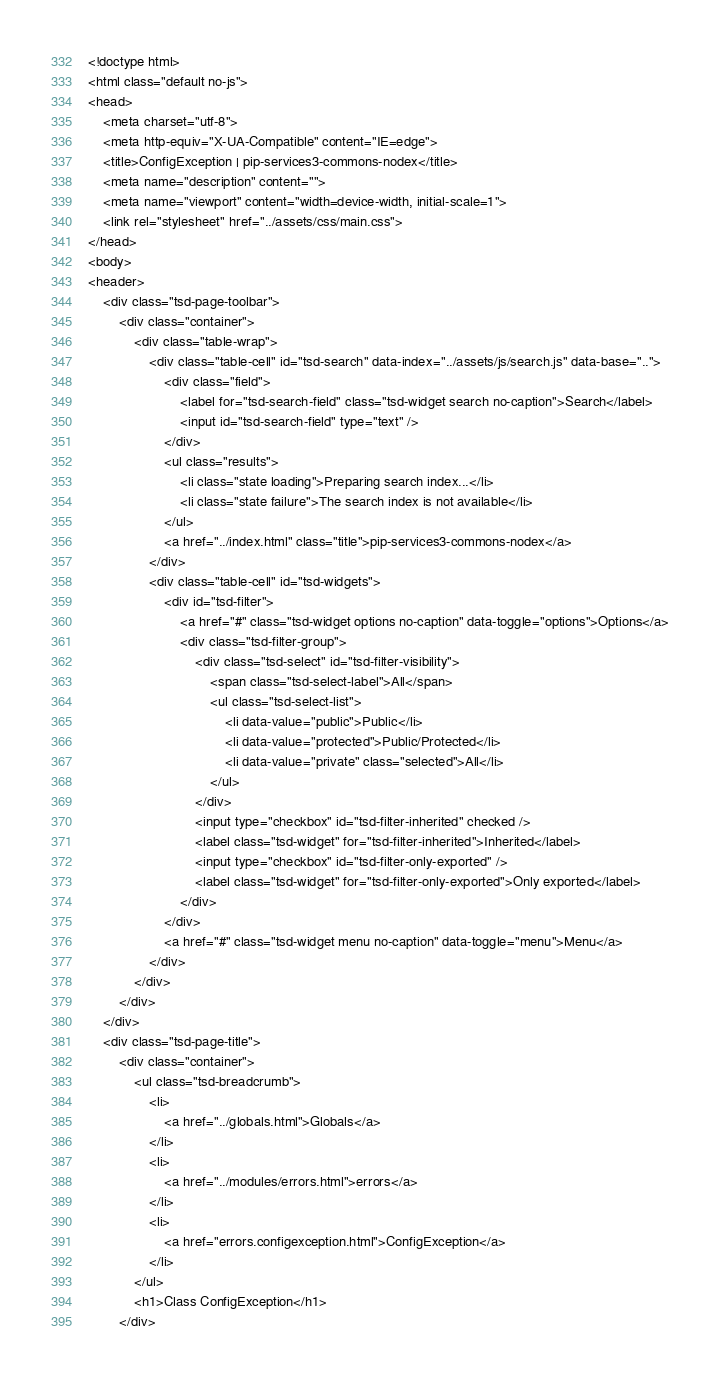<code> <loc_0><loc_0><loc_500><loc_500><_HTML_><!doctype html>
<html class="default no-js">
<head>
	<meta charset="utf-8">
	<meta http-equiv="X-UA-Compatible" content="IE=edge">
	<title>ConfigException | pip-services3-commons-nodex</title>
	<meta name="description" content="">
	<meta name="viewport" content="width=device-width, initial-scale=1">
	<link rel="stylesheet" href="../assets/css/main.css">
</head>
<body>
<header>
	<div class="tsd-page-toolbar">
		<div class="container">
			<div class="table-wrap">
				<div class="table-cell" id="tsd-search" data-index="../assets/js/search.js" data-base="..">
					<div class="field">
						<label for="tsd-search-field" class="tsd-widget search no-caption">Search</label>
						<input id="tsd-search-field" type="text" />
					</div>
					<ul class="results">
						<li class="state loading">Preparing search index...</li>
						<li class="state failure">The search index is not available</li>
					</ul>
					<a href="../index.html" class="title">pip-services3-commons-nodex</a>
				</div>
				<div class="table-cell" id="tsd-widgets">
					<div id="tsd-filter">
						<a href="#" class="tsd-widget options no-caption" data-toggle="options">Options</a>
						<div class="tsd-filter-group">
							<div class="tsd-select" id="tsd-filter-visibility">
								<span class="tsd-select-label">All</span>
								<ul class="tsd-select-list">
									<li data-value="public">Public</li>
									<li data-value="protected">Public/Protected</li>
									<li data-value="private" class="selected">All</li>
								</ul>
							</div>
							<input type="checkbox" id="tsd-filter-inherited" checked />
							<label class="tsd-widget" for="tsd-filter-inherited">Inherited</label>
							<input type="checkbox" id="tsd-filter-only-exported" />
							<label class="tsd-widget" for="tsd-filter-only-exported">Only exported</label>
						</div>
					</div>
					<a href="#" class="tsd-widget menu no-caption" data-toggle="menu">Menu</a>
				</div>
			</div>
		</div>
	</div>
	<div class="tsd-page-title">
		<div class="container">
			<ul class="tsd-breadcrumb">
				<li>
					<a href="../globals.html">Globals</a>
				</li>
				<li>
					<a href="../modules/errors.html">errors</a>
				</li>
				<li>
					<a href="errors.configexception.html">ConfigException</a>
				</li>
			</ul>
			<h1>Class ConfigException</h1>
		</div></code> 